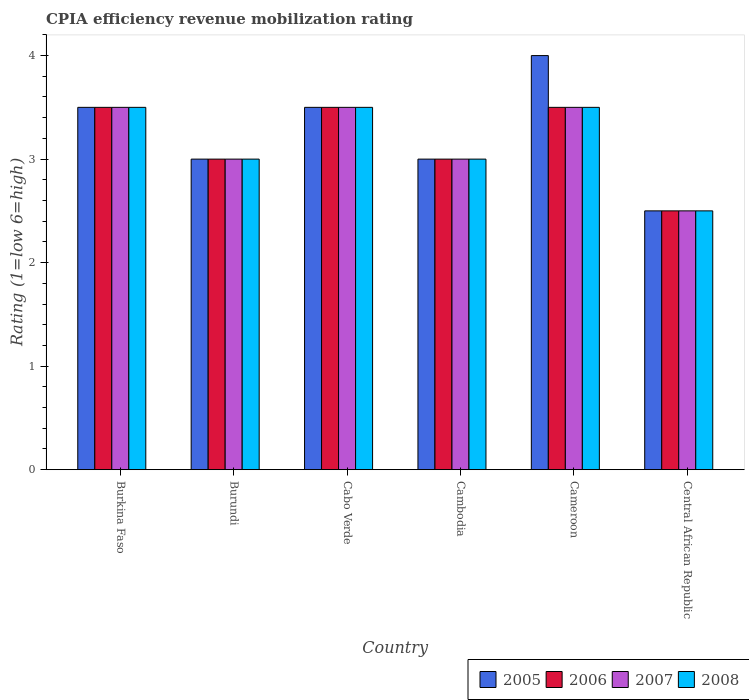How many different coloured bars are there?
Keep it short and to the point. 4. How many groups of bars are there?
Your response must be concise. 6. Are the number of bars per tick equal to the number of legend labels?
Provide a succinct answer. Yes. How many bars are there on the 4th tick from the left?
Offer a terse response. 4. How many bars are there on the 6th tick from the right?
Ensure brevity in your answer.  4. What is the label of the 4th group of bars from the left?
Your response must be concise. Cambodia. In how many cases, is the number of bars for a given country not equal to the number of legend labels?
Make the answer very short. 0. What is the CPIA rating in 2006 in Cabo Verde?
Make the answer very short. 3.5. Across all countries, what is the minimum CPIA rating in 2006?
Give a very brief answer. 2.5. In which country was the CPIA rating in 2005 maximum?
Your answer should be very brief. Cameroon. In which country was the CPIA rating in 2008 minimum?
Provide a succinct answer. Central African Republic. What is the difference between the CPIA rating in 2008 in Burundi and the CPIA rating in 2006 in Burkina Faso?
Make the answer very short. -0.5. What is the average CPIA rating in 2008 per country?
Offer a terse response. 3.17. In how many countries, is the CPIA rating in 2008 greater than 2.8?
Offer a terse response. 5. What is the ratio of the CPIA rating in 2007 in Cambodia to that in Cameroon?
Make the answer very short. 0.86. Is the CPIA rating in 2005 in Burundi less than that in Cameroon?
Offer a very short reply. Yes. Is the sum of the CPIA rating in 2007 in Burundi and Cabo Verde greater than the maximum CPIA rating in 2008 across all countries?
Your answer should be compact. Yes. Is it the case that in every country, the sum of the CPIA rating in 2008 and CPIA rating in 2005 is greater than the sum of CPIA rating in 2007 and CPIA rating in 2006?
Provide a short and direct response. No. Are all the bars in the graph horizontal?
Provide a succinct answer. No. Does the graph contain grids?
Give a very brief answer. No. What is the title of the graph?
Give a very brief answer. CPIA efficiency revenue mobilization rating. Does "1964" appear as one of the legend labels in the graph?
Your answer should be compact. No. What is the label or title of the Y-axis?
Give a very brief answer. Rating (1=low 6=high). What is the Rating (1=low 6=high) of 2008 in Burkina Faso?
Your answer should be compact. 3.5. What is the Rating (1=low 6=high) of 2005 in Burundi?
Ensure brevity in your answer.  3. What is the Rating (1=low 6=high) of 2007 in Burundi?
Ensure brevity in your answer.  3. What is the Rating (1=low 6=high) of 2005 in Cabo Verde?
Give a very brief answer. 3.5. What is the Rating (1=low 6=high) in 2006 in Cabo Verde?
Your answer should be very brief. 3.5. What is the Rating (1=low 6=high) in 2005 in Cambodia?
Make the answer very short. 3. What is the Rating (1=low 6=high) in 2006 in Cambodia?
Your answer should be compact. 3. What is the Rating (1=low 6=high) in 2007 in Cambodia?
Offer a terse response. 3. What is the Rating (1=low 6=high) in 2006 in Cameroon?
Your answer should be compact. 3.5. What is the Rating (1=low 6=high) in 2006 in Central African Republic?
Give a very brief answer. 2.5. What is the Rating (1=low 6=high) of 2008 in Central African Republic?
Offer a very short reply. 2.5. Across all countries, what is the maximum Rating (1=low 6=high) of 2005?
Offer a terse response. 4. Across all countries, what is the maximum Rating (1=low 6=high) of 2006?
Ensure brevity in your answer.  3.5. Across all countries, what is the maximum Rating (1=low 6=high) in 2007?
Offer a very short reply. 3.5. Across all countries, what is the maximum Rating (1=low 6=high) in 2008?
Provide a succinct answer. 3.5. Across all countries, what is the minimum Rating (1=low 6=high) of 2005?
Ensure brevity in your answer.  2.5. Across all countries, what is the minimum Rating (1=low 6=high) of 2006?
Your answer should be very brief. 2.5. Across all countries, what is the minimum Rating (1=low 6=high) of 2007?
Your response must be concise. 2.5. Across all countries, what is the minimum Rating (1=low 6=high) of 2008?
Offer a terse response. 2.5. What is the total Rating (1=low 6=high) in 2005 in the graph?
Ensure brevity in your answer.  19.5. What is the total Rating (1=low 6=high) of 2007 in the graph?
Make the answer very short. 19. What is the total Rating (1=low 6=high) of 2008 in the graph?
Offer a terse response. 19. What is the difference between the Rating (1=low 6=high) of 2005 in Burkina Faso and that in Burundi?
Provide a short and direct response. 0.5. What is the difference between the Rating (1=low 6=high) of 2006 in Burkina Faso and that in Burundi?
Keep it short and to the point. 0.5. What is the difference between the Rating (1=low 6=high) of 2007 in Burkina Faso and that in Burundi?
Give a very brief answer. 0.5. What is the difference between the Rating (1=low 6=high) of 2008 in Burkina Faso and that in Burundi?
Offer a very short reply. 0.5. What is the difference between the Rating (1=low 6=high) of 2005 in Burkina Faso and that in Cabo Verde?
Offer a very short reply. 0. What is the difference between the Rating (1=low 6=high) of 2008 in Burkina Faso and that in Cabo Verde?
Your answer should be very brief. 0. What is the difference between the Rating (1=low 6=high) of 2005 in Burkina Faso and that in Cambodia?
Offer a very short reply. 0.5. What is the difference between the Rating (1=low 6=high) in 2008 in Burkina Faso and that in Cambodia?
Your answer should be very brief. 0.5. What is the difference between the Rating (1=low 6=high) of 2008 in Burkina Faso and that in Cameroon?
Your response must be concise. 0. What is the difference between the Rating (1=low 6=high) in 2005 in Burundi and that in Cabo Verde?
Provide a short and direct response. -0.5. What is the difference between the Rating (1=low 6=high) in 2006 in Burundi and that in Cabo Verde?
Give a very brief answer. -0.5. What is the difference between the Rating (1=low 6=high) of 2007 in Burundi and that in Cabo Verde?
Your answer should be very brief. -0.5. What is the difference between the Rating (1=low 6=high) of 2006 in Burundi and that in Cambodia?
Provide a short and direct response. 0. What is the difference between the Rating (1=low 6=high) of 2008 in Burundi and that in Cambodia?
Your response must be concise. 0. What is the difference between the Rating (1=low 6=high) in 2005 in Burundi and that in Cameroon?
Give a very brief answer. -1. What is the difference between the Rating (1=low 6=high) in 2008 in Burundi and that in Cameroon?
Your response must be concise. -0.5. What is the difference between the Rating (1=low 6=high) of 2005 in Burundi and that in Central African Republic?
Give a very brief answer. 0.5. What is the difference between the Rating (1=low 6=high) of 2006 in Burundi and that in Central African Republic?
Provide a short and direct response. 0.5. What is the difference between the Rating (1=low 6=high) of 2007 in Burundi and that in Central African Republic?
Offer a terse response. 0.5. What is the difference between the Rating (1=low 6=high) in 2008 in Burundi and that in Central African Republic?
Your answer should be very brief. 0.5. What is the difference between the Rating (1=low 6=high) in 2006 in Cabo Verde and that in Cambodia?
Offer a terse response. 0.5. What is the difference between the Rating (1=low 6=high) of 2005 in Cabo Verde and that in Cameroon?
Ensure brevity in your answer.  -0.5. What is the difference between the Rating (1=low 6=high) of 2006 in Cabo Verde and that in Central African Republic?
Keep it short and to the point. 1. What is the difference between the Rating (1=low 6=high) of 2007 in Cabo Verde and that in Central African Republic?
Provide a succinct answer. 1. What is the difference between the Rating (1=low 6=high) of 2008 in Cabo Verde and that in Central African Republic?
Provide a succinct answer. 1. What is the difference between the Rating (1=low 6=high) of 2006 in Cambodia and that in Cameroon?
Your answer should be compact. -0.5. What is the difference between the Rating (1=low 6=high) of 2007 in Cambodia and that in Cameroon?
Offer a very short reply. -0.5. What is the difference between the Rating (1=low 6=high) of 2008 in Cambodia and that in Cameroon?
Provide a succinct answer. -0.5. What is the difference between the Rating (1=low 6=high) in 2005 in Cambodia and that in Central African Republic?
Offer a terse response. 0.5. What is the difference between the Rating (1=low 6=high) in 2005 in Cameroon and that in Central African Republic?
Make the answer very short. 1.5. What is the difference between the Rating (1=low 6=high) in 2006 in Cameroon and that in Central African Republic?
Give a very brief answer. 1. What is the difference between the Rating (1=low 6=high) of 2005 in Burkina Faso and the Rating (1=low 6=high) of 2006 in Burundi?
Offer a terse response. 0.5. What is the difference between the Rating (1=low 6=high) in 2005 in Burkina Faso and the Rating (1=low 6=high) in 2007 in Burundi?
Offer a terse response. 0.5. What is the difference between the Rating (1=low 6=high) in 2006 in Burkina Faso and the Rating (1=low 6=high) in 2008 in Burundi?
Provide a succinct answer. 0.5. What is the difference between the Rating (1=low 6=high) in 2005 in Burkina Faso and the Rating (1=low 6=high) in 2006 in Cabo Verde?
Make the answer very short. 0. What is the difference between the Rating (1=low 6=high) in 2006 in Burkina Faso and the Rating (1=low 6=high) in 2008 in Cabo Verde?
Provide a succinct answer. 0. What is the difference between the Rating (1=low 6=high) in 2007 in Burkina Faso and the Rating (1=low 6=high) in 2008 in Cabo Verde?
Give a very brief answer. 0. What is the difference between the Rating (1=low 6=high) of 2005 in Burkina Faso and the Rating (1=low 6=high) of 2006 in Cambodia?
Your answer should be very brief. 0.5. What is the difference between the Rating (1=low 6=high) in 2005 in Burkina Faso and the Rating (1=low 6=high) in 2007 in Cambodia?
Provide a succinct answer. 0.5. What is the difference between the Rating (1=low 6=high) of 2005 in Burkina Faso and the Rating (1=low 6=high) of 2008 in Cambodia?
Make the answer very short. 0.5. What is the difference between the Rating (1=low 6=high) of 2006 in Burkina Faso and the Rating (1=low 6=high) of 2008 in Cambodia?
Offer a very short reply. 0.5. What is the difference between the Rating (1=low 6=high) of 2005 in Burkina Faso and the Rating (1=low 6=high) of 2007 in Cameroon?
Your answer should be compact. 0. What is the difference between the Rating (1=low 6=high) of 2005 in Burkina Faso and the Rating (1=low 6=high) of 2008 in Cameroon?
Make the answer very short. 0. What is the difference between the Rating (1=low 6=high) in 2006 in Burkina Faso and the Rating (1=low 6=high) in 2007 in Cameroon?
Keep it short and to the point. 0. What is the difference between the Rating (1=low 6=high) in 2006 in Burkina Faso and the Rating (1=low 6=high) in 2008 in Central African Republic?
Provide a short and direct response. 1. What is the difference between the Rating (1=low 6=high) of 2006 in Burundi and the Rating (1=low 6=high) of 2007 in Cabo Verde?
Your answer should be very brief. -0.5. What is the difference between the Rating (1=low 6=high) of 2007 in Burundi and the Rating (1=low 6=high) of 2008 in Cabo Verde?
Offer a very short reply. -0.5. What is the difference between the Rating (1=low 6=high) in 2005 in Burundi and the Rating (1=low 6=high) in 2006 in Cameroon?
Offer a terse response. -0.5. What is the difference between the Rating (1=low 6=high) of 2007 in Burundi and the Rating (1=low 6=high) of 2008 in Cameroon?
Ensure brevity in your answer.  -0.5. What is the difference between the Rating (1=low 6=high) of 2005 in Burundi and the Rating (1=low 6=high) of 2007 in Central African Republic?
Your answer should be compact. 0.5. What is the difference between the Rating (1=low 6=high) of 2006 in Burundi and the Rating (1=low 6=high) of 2007 in Central African Republic?
Your answer should be very brief. 0.5. What is the difference between the Rating (1=low 6=high) in 2007 in Burundi and the Rating (1=low 6=high) in 2008 in Central African Republic?
Offer a very short reply. 0.5. What is the difference between the Rating (1=low 6=high) in 2005 in Cabo Verde and the Rating (1=low 6=high) in 2007 in Cambodia?
Provide a short and direct response. 0.5. What is the difference between the Rating (1=low 6=high) in 2005 in Cabo Verde and the Rating (1=low 6=high) in 2008 in Cambodia?
Offer a very short reply. 0.5. What is the difference between the Rating (1=low 6=high) in 2006 in Cabo Verde and the Rating (1=low 6=high) in 2007 in Cambodia?
Your answer should be compact. 0.5. What is the difference between the Rating (1=low 6=high) in 2006 in Cabo Verde and the Rating (1=low 6=high) in 2008 in Cambodia?
Make the answer very short. 0.5. What is the difference between the Rating (1=low 6=high) in 2007 in Cabo Verde and the Rating (1=low 6=high) in 2008 in Cambodia?
Provide a short and direct response. 0.5. What is the difference between the Rating (1=low 6=high) in 2005 in Cabo Verde and the Rating (1=low 6=high) in 2007 in Cameroon?
Make the answer very short. 0. What is the difference between the Rating (1=low 6=high) of 2007 in Cabo Verde and the Rating (1=low 6=high) of 2008 in Cameroon?
Offer a terse response. 0. What is the difference between the Rating (1=low 6=high) of 2005 in Cabo Verde and the Rating (1=low 6=high) of 2006 in Central African Republic?
Make the answer very short. 1. What is the difference between the Rating (1=low 6=high) of 2005 in Cabo Verde and the Rating (1=low 6=high) of 2008 in Central African Republic?
Keep it short and to the point. 1. What is the difference between the Rating (1=low 6=high) of 2006 in Cabo Verde and the Rating (1=low 6=high) of 2007 in Central African Republic?
Your response must be concise. 1. What is the difference between the Rating (1=low 6=high) of 2006 in Cabo Verde and the Rating (1=low 6=high) of 2008 in Central African Republic?
Offer a terse response. 1. What is the difference between the Rating (1=low 6=high) of 2007 in Cabo Verde and the Rating (1=low 6=high) of 2008 in Central African Republic?
Make the answer very short. 1. What is the difference between the Rating (1=low 6=high) in 2005 in Cambodia and the Rating (1=low 6=high) in 2008 in Cameroon?
Make the answer very short. -0.5. What is the difference between the Rating (1=low 6=high) of 2006 in Cambodia and the Rating (1=low 6=high) of 2007 in Cameroon?
Provide a succinct answer. -0.5. What is the difference between the Rating (1=low 6=high) of 2006 in Cambodia and the Rating (1=low 6=high) of 2008 in Cameroon?
Make the answer very short. -0.5. What is the difference between the Rating (1=low 6=high) of 2007 in Cambodia and the Rating (1=low 6=high) of 2008 in Cameroon?
Give a very brief answer. -0.5. What is the difference between the Rating (1=low 6=high) in 2006 in Cambodia and the Rating (1=low 6=high) in 2008 in Central African Republic?
Give a very brief answer. 0.5. What is the difference between the Rating (1=low 6=high) of 2007 in Cambodia and the Rating (1=low 6=high) of 2008 in Central African Republic?
Offer a very short reply. 0.5. What is the difference between the Rating (1=low 6=high) in 2005 in Cameroon and the Rating (1=low 6=high) in 2006 in Central African Republic?
Offer a very short reply. 1.5. What is the difference between the Rating (1=low 6=high) of 2005 in Cameroon and the Rating (1=low 6=high) of 2007 in Central African Republic?
Provide a short and direct response. 1.5. What is the difference between the Rating (1=low 6=high) of 2005 in Cameroon and the Rating (1=low 6=high) of 2008 in Central African Republic?
Ensure brevity in your answer.  1.5. What is the difference between the Rating (1=low 6=high) in 2006 in Cameroon and the Rating (1=low 6=high) in 2007 in Central African Republic?
Ensure brevity in your answer.  1. What is the difference between the Rating (1=low 6=high) of 2006 in Cameroon and the Rating (1=low 6=high) of 2008 in Central African Republic?
Your answer should be very brief. 1. What is the difference between the Rating (1=low 6=high) of 2007 in Cameroon and the Rating (1=low 6=high) of 2008 in Central African Republic?
Your answer should be compact. 1. What is the average Rating (1=low 6=high) of 2005 per country?
Offer a terse response. 3.25. What is the average Rating (1=low 6=high) in 2006 per country?
Provide a succinct answer. 3.17. What is the average Rating (1=low 6=high) in 2007 per country?
Ensure brevity in your answer.  3.17. What is the average Rating (1=low 6=high) of 2008 per country?
Make the answer very short. 3.17. What is the difference between the Rating (1=low 6=high) in 2005 and Rating (1=low 6=high) in 2008 in Burkina Faso?
Provide a succinct answer. 0. What is the difference between the Rating (1=low 6=high) of 2006 and Rating (1=low 6=high) of 2007 in Burkina Faso?
Keep it short and to the point. 0. What is the difference between the Rating (1=low 6=high) of 2005 and Rating (1=low 6=high) of 2007 in Burundi?
Offer a very short reply. 0. What is the difference between the Rating (1=low 6=high) in 2006 and Rating (1=low 6=high) in 2008 in Burundi?
Offer a terse response. 0. What is the difference between the Rating (1=low 6=high) of 2005 and Rating (1=low 6=high) of 2007 in Cabo Verde?
Provide a succinct answer. 0. What is the difference between the Rating (1=low 6=high) of 2005 and Rating (1=low 6=high) of 2006 in Cambodia?
Give a very brief answer. 0. What is the difference between the Rating (1=low 6=high) of 2005 and Rating (1=low 6=high) of 2007 in Cambodia?
Your answer should be compact. 0. What is the difference between the Rating (1=low 6=high) of 2005 and Rating (1=low 6=high) of 2008 in Cambodia?
Your answer should be compact. 0. What is the difference between the Rating (1=low 6=high) of 2006 and Rating (1=low 6=high) of 2007 in Cambodia?
Offer a very short reply. 0. What is the difference between the Rating (1=low 6=high) in 2005 and Rating (1=low 6=high) in 2006 in Cameroon?
Make the answer very short. 0.5. What is the difference between the Rating (1=low 6=high) of 2005 and Rating (1=low 6=high) of 2007 in Cameroon?
Offer a very short reply. 0.5. What is the difference between the Rating (1=low 6=high) in 2005 and Rating (1=low 6=high) in 2008 in Cameroon?
Keep it short and to the point. 0.5. What is the difference between the Rating (1=low 6=high) in 2006 and Rating (1=low 6=high) in 2007 in Cameroon?
Your response must be concise. 0. What is the difference between the Rating (1=low 6=high) in 2006 and Rating (1=low 6=high) in 2008 in Cameroon?
Offer a very short reply. 0. What is the difference between the Rating (1=low 6=high) in 2005 and Rating (1=low 6=high) in 2007 in Central African Republic?
Your response must be concise. 0. What is the difference between the Rating (1=low 6=high) of 2007 and Rating (1=low 6=high) of 2008 in Central African Republic?
Make the answer very short. 0. What is the ratio of the Rating (1=low 6=high) in 2005 in Burkina Faso to that in Burundi?
Make the answer very short. 1.17. What is the ratio of the Rating (1=low 6=high) in 2006 in Burkina Faso to that in Burundi?
Make the answer very short. 1.17. What is the ratio of the Rating (1=low 6=high) in 2007 in Burkina Faso to that in Burundi?
Offer a terse response. 1.17. What is the ratio of the Rating (1=low 6=high) in 2005 in Burkina Faso to that in Cabo Verde?
Give a very brief answer. 1. What is the ratio of the Rating (1=low 6=high) in 2006 in Burkina Faso to that in Cabo Verde?
Offer a terse response. 1. What is the ratio of the Rating (1=low 6=high) of 2008 in Burkina Faso to that in Cabo Verde?
Offer a terse response. 1. What is the ratio of the Rating (1=low 6=high) of 2006 in Burkina Faso to that in Cambodia?
Make the answer very short. 1.17. What is the ratio of the Rating (1=low 6=high) in 2006 in Burkina Faso to that in Cameroon?
Keep it short and to the point. 1. What is the ratio of the Rating (1=low 6=high) in 2008 in Burkina Faso to that in Cameroon?
Make the answer very short. 1. What is the ratio of the Rating (1=low 6=high) in 2005 in Burkina Faso to that in Central African Republic?
Your response must be concise. 1.4. What is the ratio of the Rating (1=low 6=high) of 2005 in Burundi to that in Cabo Verde?
Provide a short and direct response. 0.86. What is the ratio of the Rating (1=low 6=high) of 2007 in Burundi to that in Cabo Verde?
Make the answer very short. 0.86. What is the ratio of the Rating (1=low 6=high) of 2008 in Burundi to that in Cabo Verde?
Ensure brevity in your answer.  0.86. What is the ratio of the Rating (1=low 6=high) of 2005 in Burundi to that in Cambodia?
Make the answer very short. 1. What is the ratio of the Rating (1=low 6=high) in 2008 in Burundi to that in Cambodia?
Keep it short and to the point. 1. What is the ratio of the Rating (1=low 6=high) in 2005 in Burundi to that in Cameroon?
Keep it short and to the point. 0.75. What is the ratio of the Rating (1=low 6=high) in 2006 in Burundi to that in Cameroon?
Your answer should be compact. 0.86. What is the ratio of the Rating (1=low 6=high) in 2005 in Burundi to that in Central African Republic?
Provide a succinct answer. 1.2. What is the ratio of the Rating (1=low 6=high) of 2006 in Burundi to that in Central African Republic?
Provide a short and direct response. 1.2. What is the ratio of the Rating (1=low 6=high) in 2007 in Burundi to that in Central African Republic?
Make the answer very short. 1.2. What is the ratio of the Rating (1=low 6=high) of 2008 in Burundi to that in Central African Republic?
Keep it short and to the point. 1.2. What is the ratio of the Rating (1=low 6=high) in 2007 in Cabo Verde to that in Cambodia?
Your response must be concise. 1.17. What is the ratio of the Rating (1=low 6=high) in 2008 in Cabo Verde to that in Cambodia?
Provide a short and direct response. 1.17. What is the ratio of the Rating (1=low 6=high) in 2006 in Cabo Verde to that in Cameroon?
Offer a very short reply. 1. What is the ratio of the Rating (1=low 6=high) of 2006 in Cabo Verde to that in Central African Republic?
Provide a succinct answer. 1.4. What is the ratio of the Rating (1=low 6=high) in 2007 in Cabo Verde to that in Central African Republic?
Make the answer very short. 1.4. What is the ratio of the Rating (1=low 6=high) of 2008 in Cabo Verde to that in Central African Republic?
Make the answer very short. 1.4. What is the ratio of the Rating (1=low 6=high) of 2006 in Cambodia to that in Cameroon?
Offer a terse response. 0.86. What is the ratio of the Rating (1=low 6=high) in 2008 in Cambodia to that in Cameroon?
Provide a short and direct response. 0.86. What is the ratio of the Rating (1=low 6=high) of 2005 in Cambodia to that in Central African Republic?
Offer a very short reply. 1.2. What is the ratio of the Rating (1=low 6=high) of 2008 in Cambodia to that in Central African Republic?
Your response must be concise. 1.2. What is the ratio of the Rating (1=low 6=high) of 2005 in Cameroon to that in Central African Republic?
Make the answer very short. 1.6. What is the ratio of the Rating (1=low 6=high) in 2006 in Cameroon to that in Central African Republic?
Offer a terse response. 1.4. What is the difference between the highest and the second highest Rating (1=low 6=high) of 2007?
Your answer should be compact. 0. What is the difference between the highest and the second highest Rating (1=low 6=high) of 2008?
Keep it short and to the point. 0. What is the difference between the highest and the lowest Rating (1=low 6=high) of 2005?
Offer a terse response. 1.5. What is the difference between the highest and the lowest Rating (1=low 6=high) in 2007?
Offer a terse response. 1. What is the difference between the highest and the lowest Rating (1=low 6=high) of 2008?
Your answer should be very brief. 1. 